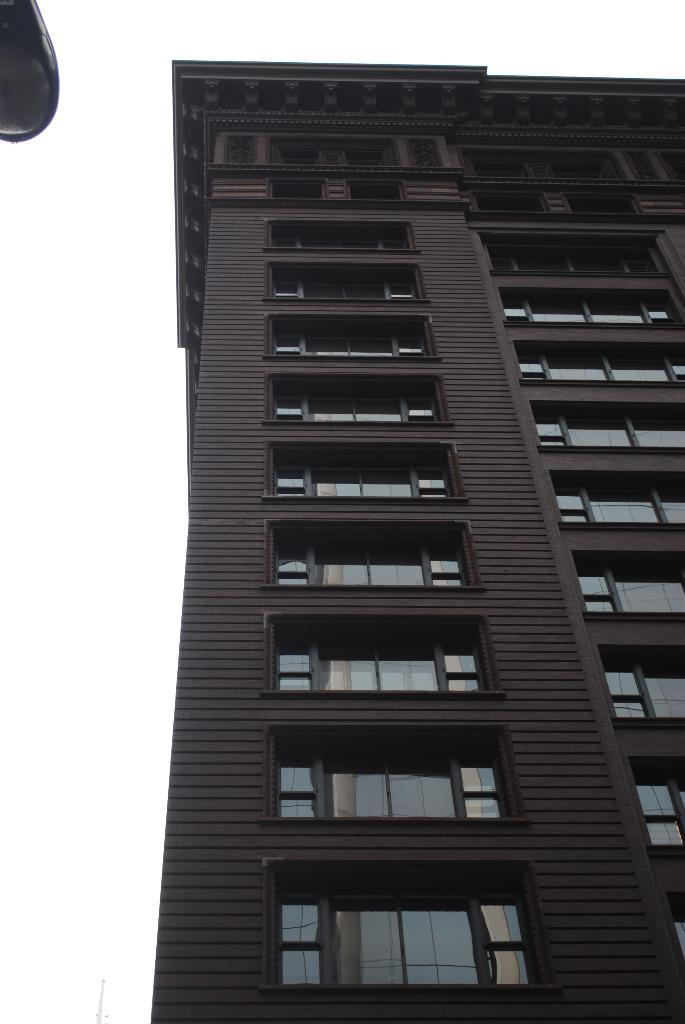What type of structure is visible in the image? There is a building in the picture. How would you describe the weather based on the image? The sky is cloudy in the picture, suggesting overcast or potentially rainy weather. Can you identify any additional objects in the image? Yes, there appears to be a pole light on the top left of the image. What type of club is being used to control the badge in the image? There is no club, control, or badge present in the image. 